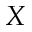Convert formula to latex. <formula><loc_0><loc_0><loc_500><loc_500>X</formula> 